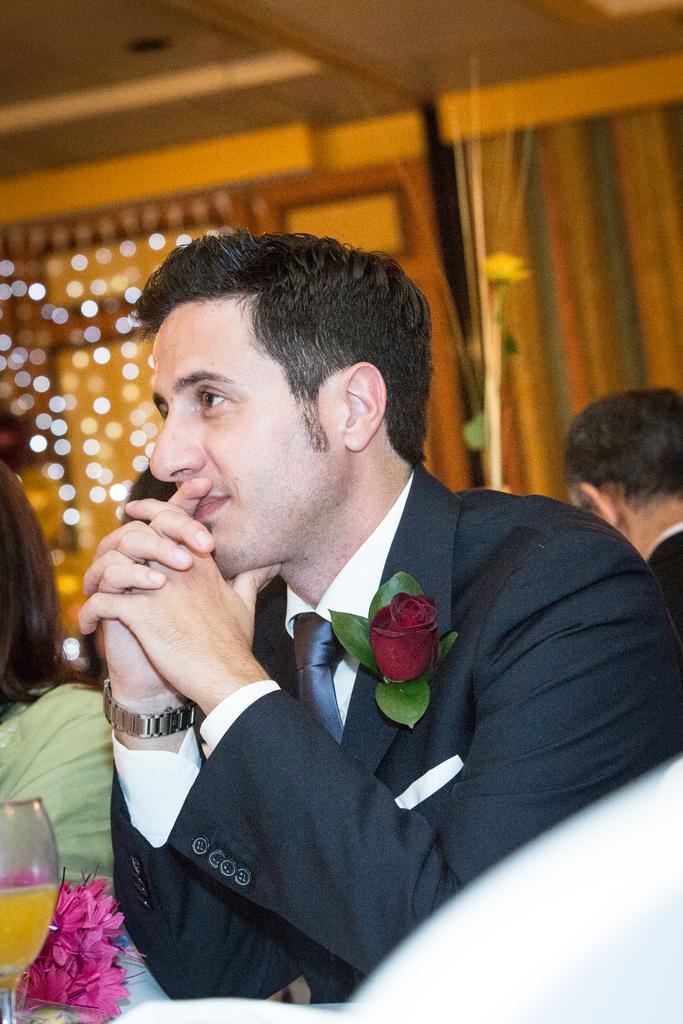Could you give a brief overview of what you see in this image? In this picture we can see a man wearing a blazer, tie, watch and smiling and beside him we can see a woman and in front of him we can see a glass, flowers and at the back of him we can see some people, curtains, lights. 